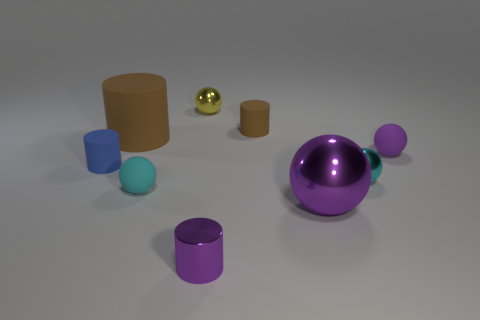Subtract all cyan spheres. How many were subtracted if there are1cyan spheres left? 1 Subtract all tiny blue rubber cylinders. How many cylinders are left? 3 Add 1 red matte objects. How many objects exist? 10 Subtract all brown cylinders. How many cylinders are left? 2 Subtract 1 cylinders. How many cylinders are left? 3 Subtract all red cylinders. Subtract all blue spheres. How many cylinders are left? 4 Add 5 cyan matte objects. How many cyan matte objects exist? 6 Subtract 0 blue balls. How many objects are left? 9 Subtract all cylinders. How many objects are left? 5 Subtract all red cylinders. How many purple balls are left? 2 